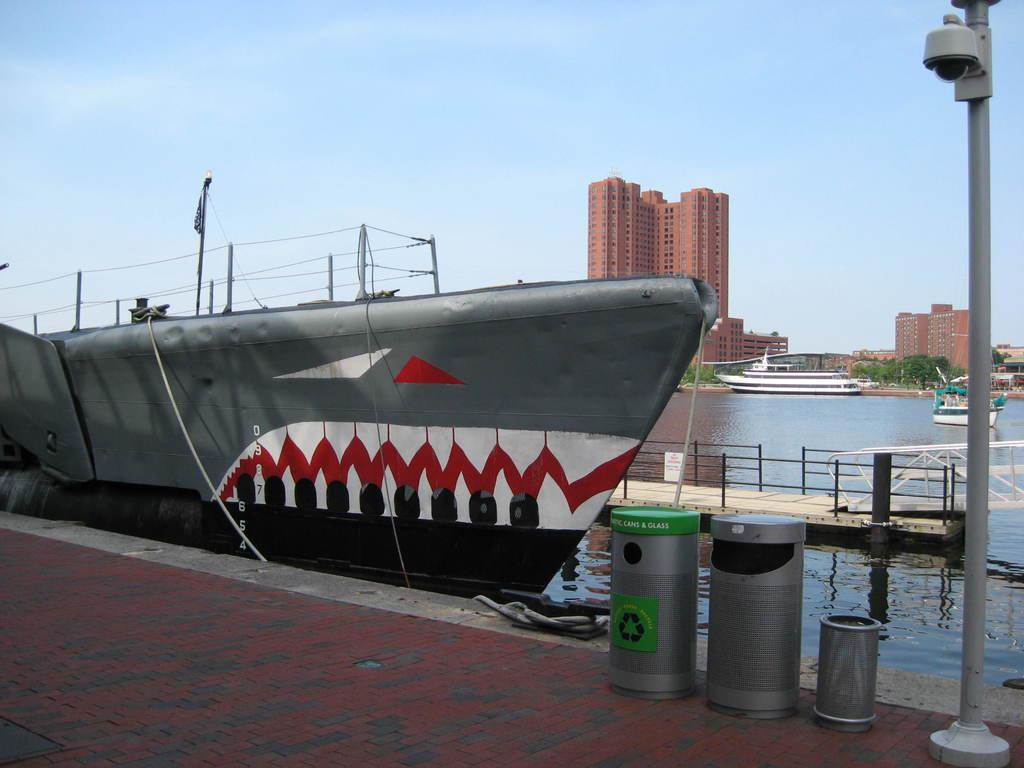<image>
Share a concise interpretation of the image provided. A trash can on a brick pier says it is for cans and glass. 